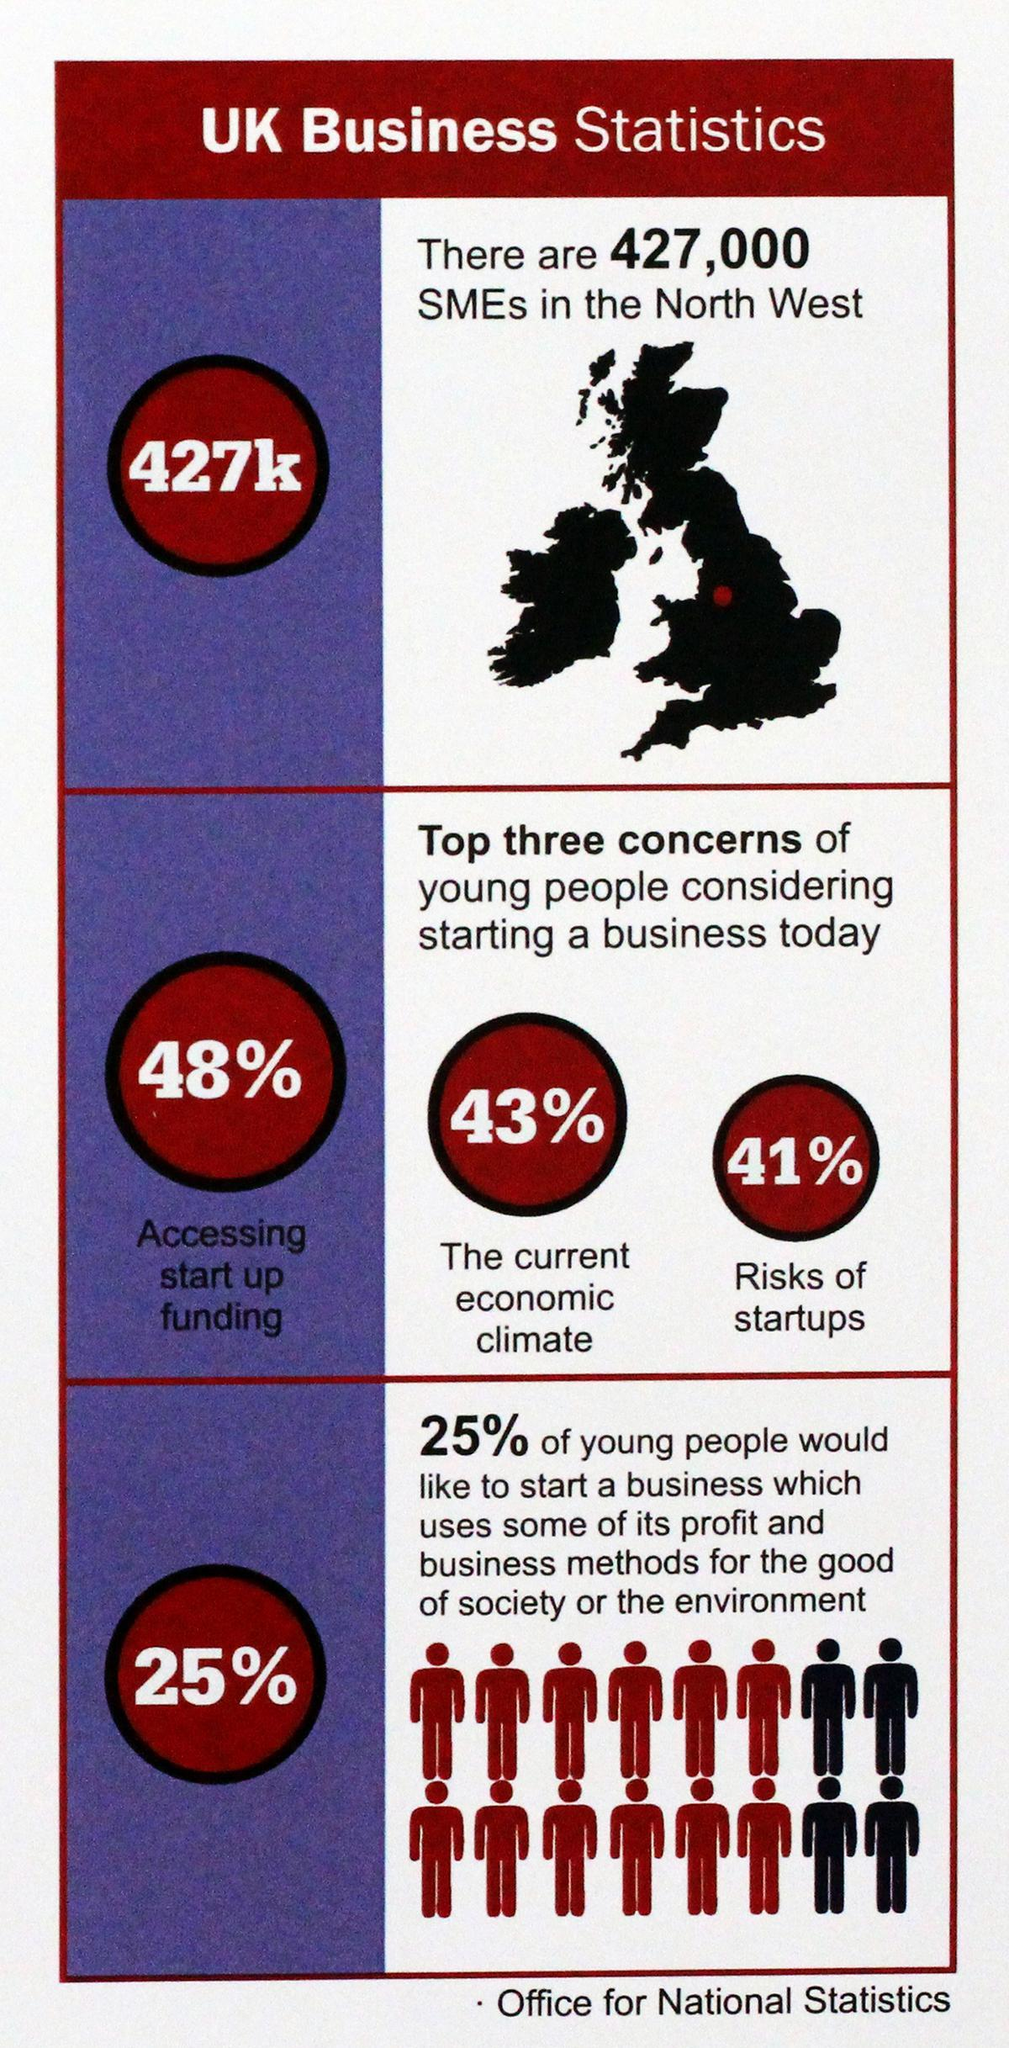what is young people most concerned about startups apart from funds?
Answer the question with a short phrase. the current economic climate what is young people most concerned about startups apart from funds or economic climate? Risks of startups what is young people most concerned about considering startup? accessing startup funding 